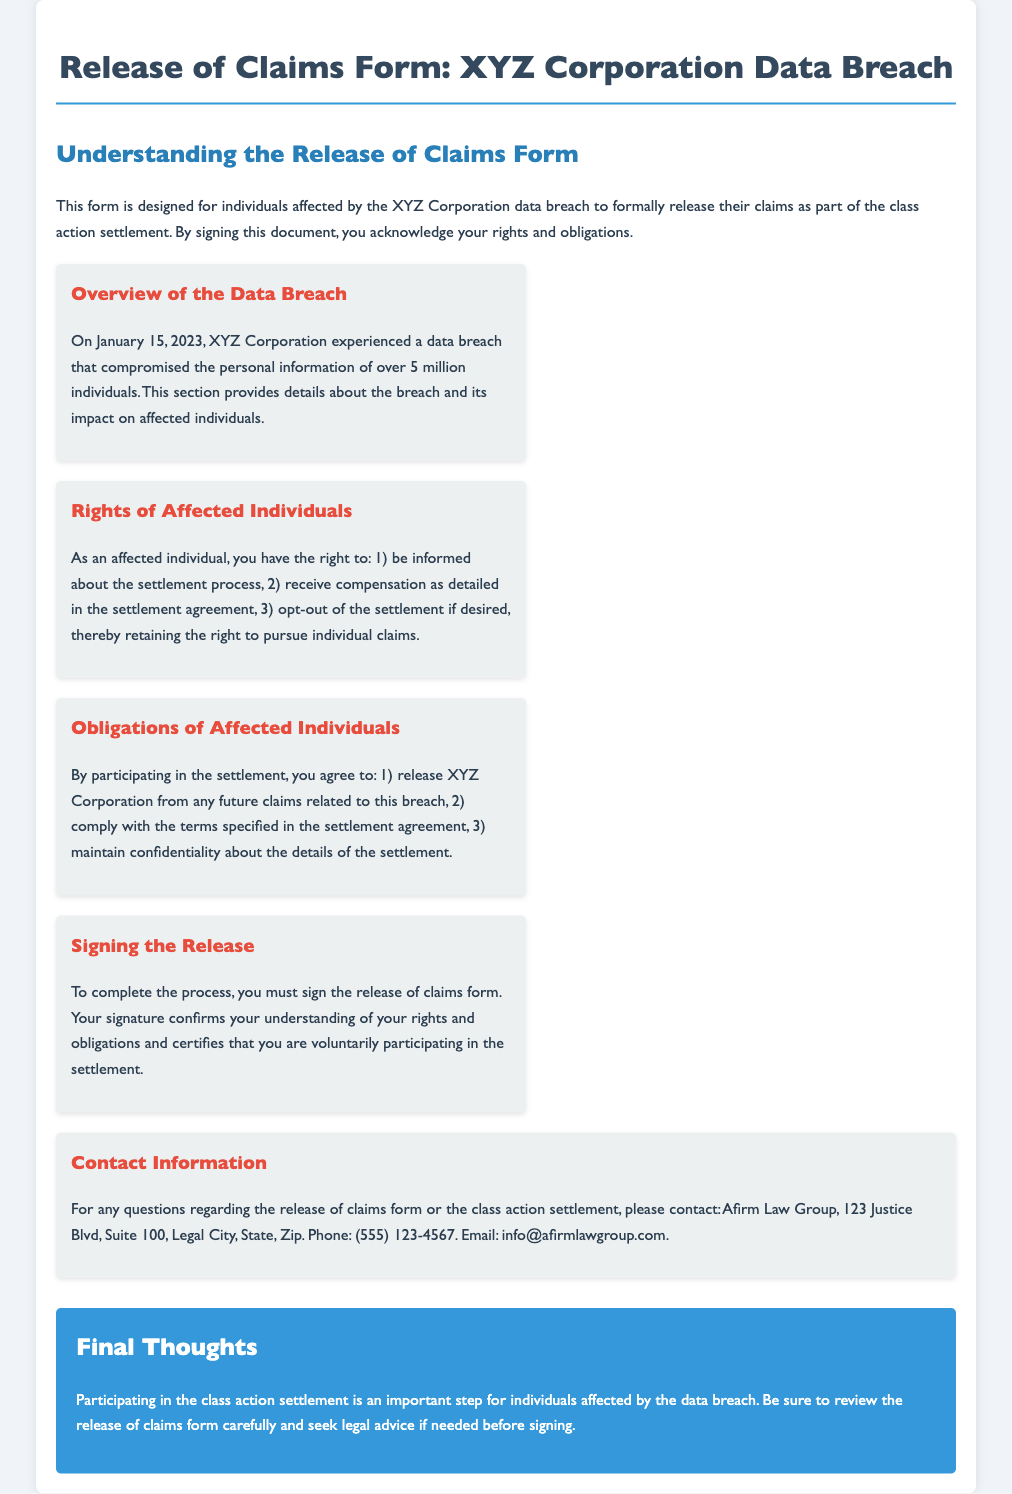What date did the data breach occur? The data breach occurred on January 15, 2023, as mentioned in the overview section.
Answer: January 15, 2023 How many individuals were affected by the data breach? The document states that the data breach compromised the personal information of over 5 million individuals.
Answer: Over 5 million What is one right of affected individuals? The document lists that affected individuals have the right to be informed about the settlement process.
Answer: Be informed about the settlement process What must individuals do to complete the process? To complete the process, individuals must sign the release of claims form.
Answer: Sign the release of claims form What does signing the release confirm? Signing the release confirms understanding of rights and obligations and voluntary participation in the settlement.
Answer: Understanding of rights and obligations and voluntary participation What is one obligation of affected individuals? One obligation is to release XYZ Corporation from any future claims related to this breach.
Answer: Release XYZ Corporation from any future claims Who should individuals contact for questions regarding the form? The contact information provided in the document lists Afirm Law Group for questions related to the release of claims form.
Answer: Afirm Law Group What is the purpose of the release of claims form? The purpose of the form is to formally release claims as part of the class action settlement.
Answer: Formally release claims as part of the class action settlement 